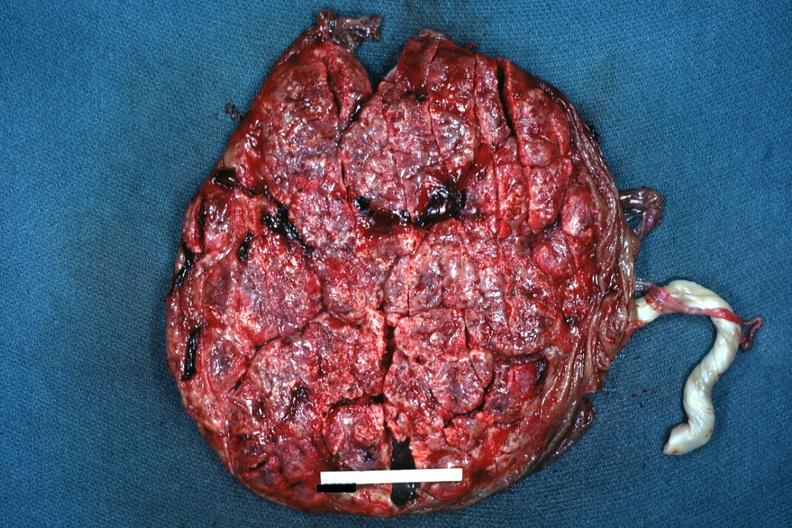what does this image show?
Answer the question using a single word or phrase. Seen from fetal surface term placenta 